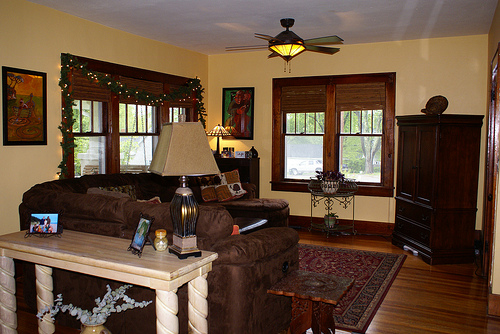Please provide a short description for this region: [0.0, 0.6, 0.44, 0.83]. A light wood table with spiral designs on its legs. 